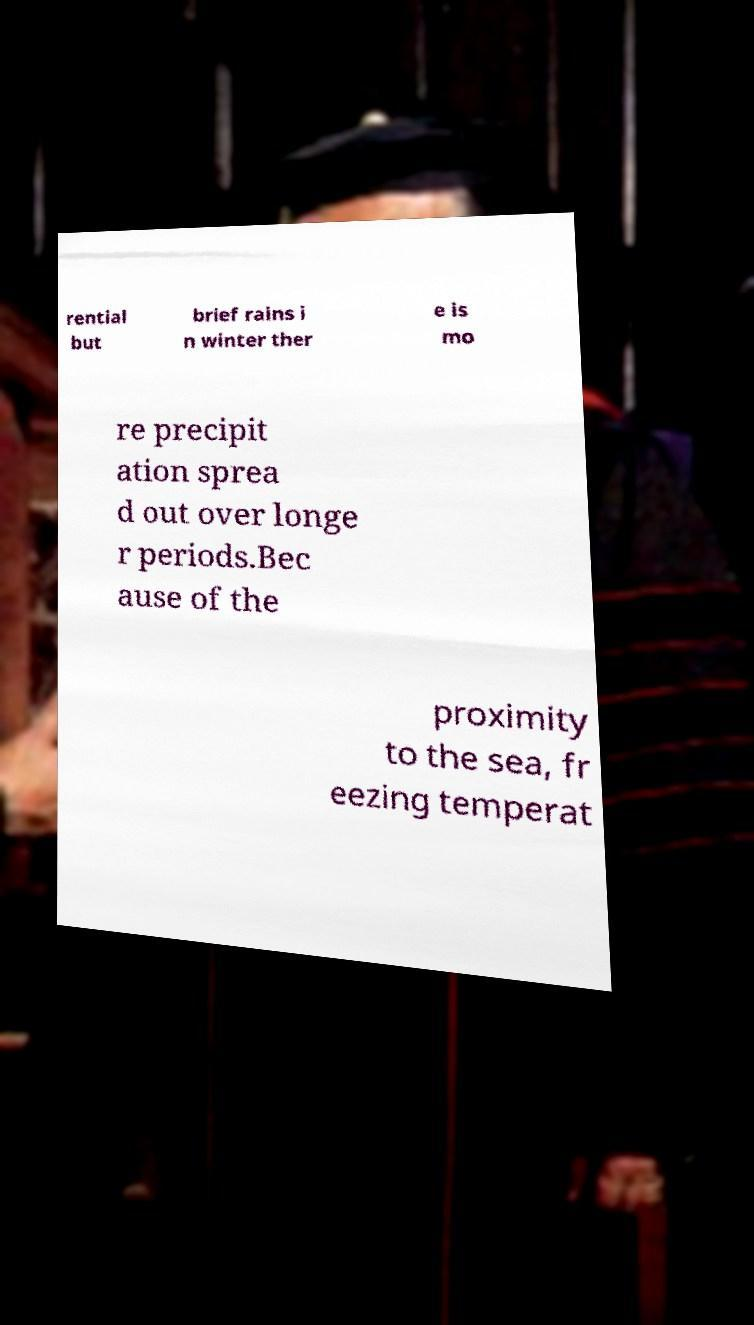Could you assist in decoding the text presented in this image and type it out clearly? rential but brief rains i n winter ther e is mo re precipit ation sprea d out over longe r periods.Bec ause of the proximity to the sea, fr eezing temperat 